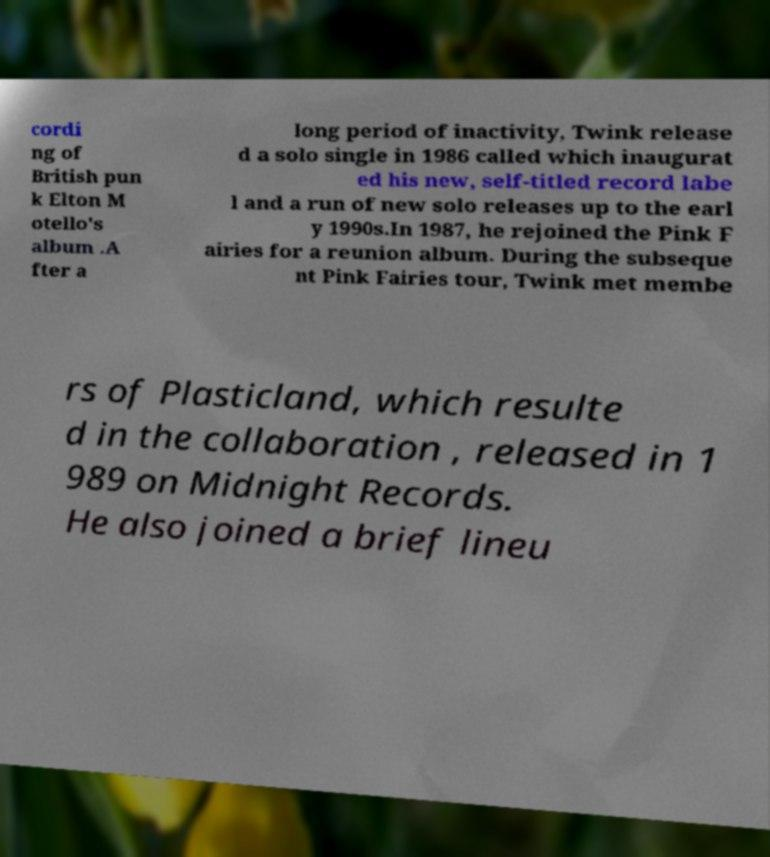For documentation purposes, I need the text within this image transcribed. Could you provide that? cordi ng of British pun k Elton M otello's album .A fter a long period of inactivity, Twink release d a solo single in 1986 called which inaugurat ed his new, self-titled record labe l and a run of new solo releases up to the earl y 1990s.In 1987, he rejoined the Pink F airies for a reunion album. During the subseque nt Pink Fairies tour, Twink met membe rs of Plasticland, which resulte d in the collaboration , released in 1 989 on Midnight Records. He also joined a brief lineu 